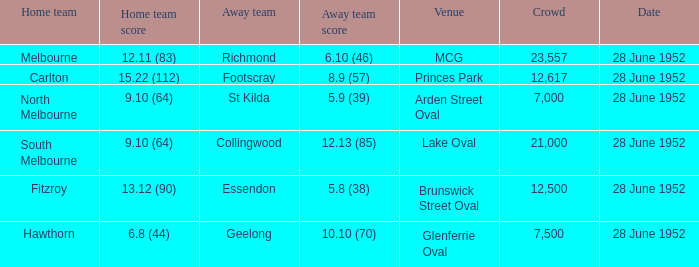What is the away team when north melbourne is at home? St Kilda. 